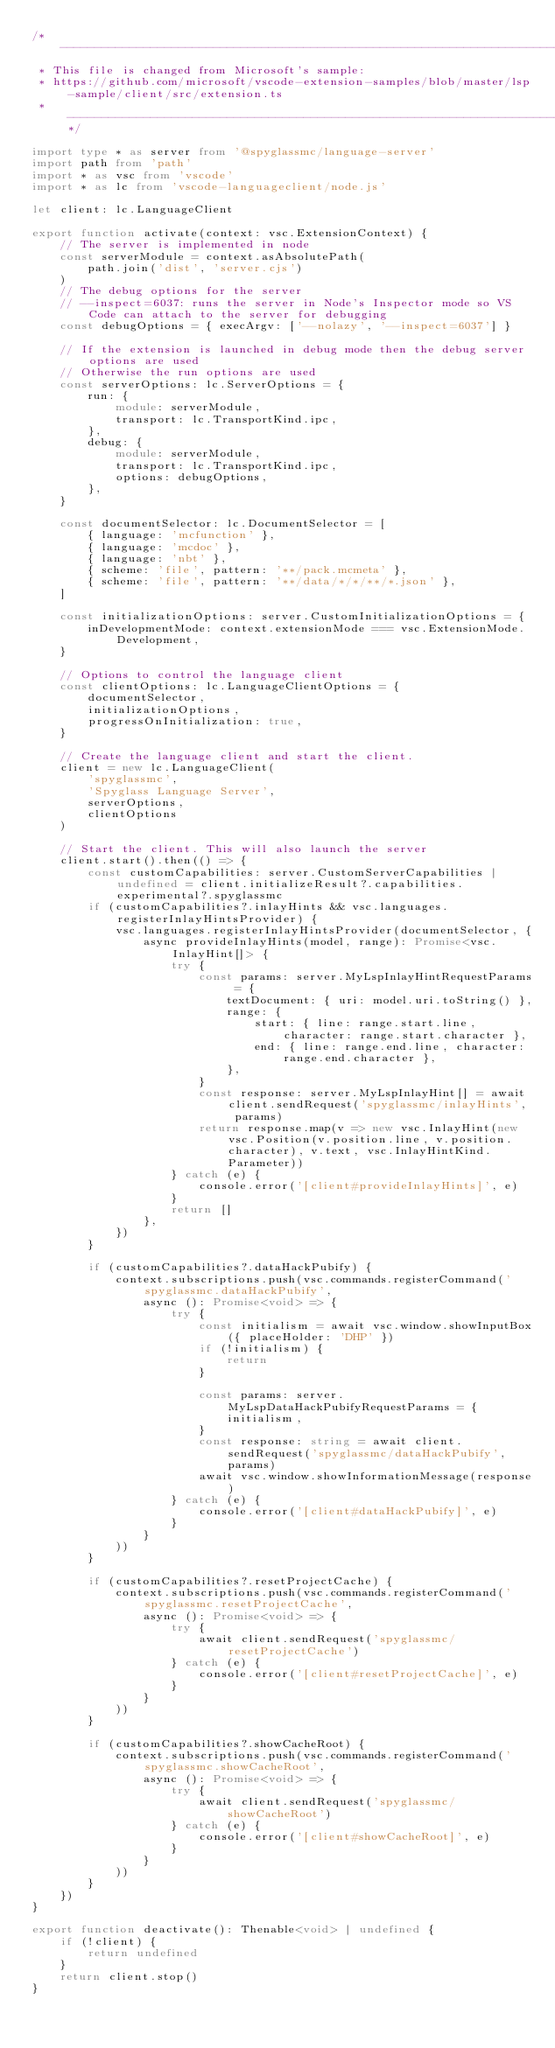<code> <loc_0><loc_0><loc_500><loc_500><_TypeScript_>/* --------------------------------------------------------------------------------------------
 * This file is changed from Microsoft's sample:
 * https://github.com/microsoft/vscode-extension-samples/blob/master/lsp-sample/client/src/extension.ts
 * ------------------------------------------------------------------------------------------*/

import type * as server from '@spyglassmc/language-server'
import path from 'path'
import * as vsc from 'vscode'
import * as lc from 'vscode-languageclient/node.js'

let client: lc.LanguageClient

export function activate(context: vsc.ExtensionContext) {
	// The server is implemented in node
	const serverModule = context.asAbsolutePath(
		path.join('dist', 'server.cjs')
	)
	// The debug options for the server
	// --inspect=6037: runs the server in Node's Inspector mode so VS Code can attach to the server for debugging
	const debugOptions = { execArgv: ['--nolazy', '--inspect=6037'] }

	// If the extension is launched in debug mode then the debug server options are used
	// Otherwise the run options are used
	const serverOptions: lc.ServerOptions = {
		run: {
			module: serverModule,
			transport: lc.TransportKind.ipc,
		},
		debug: {
			module: serverModule,
			transport: lc.TransportKind.ipc,
			options: debugOptions,
		},
	}

	const documentSelector: lc.DocumentSelector = [
		{ language: 'mcfunction' },
		{ language: 'mcdoc' },
		{ language: 'nbt' },
		{ scheme: 'file', pattern: '**/pack.mcmeta' },
		{ scheme: 'file', pattern: '**/data/*/*/**/*.json' },
	]

	const initializationOptions: server.CustomInitializationOptions = {
		inDevelopmentMode: context.extensionMode === vsc.ExtensionMode.Development,
	}

	// Options to control the language client
	const clientOptions: lc.LanguageClientOptions = {
		documentSelector,
		initializationOptions,
		progressOnInitialization: true,
	}

	// Create the language client and start the client.
	client = new lc.LanguageClient(
		'spyglassmc',
		'Spyglass Language Server',
		serverOptions,
		clientOptions
	)

	// Start the client. This will also launch the server
	client.start().then(() => {
		const customCapabilities: server.CustomServerCapabilities | undefined = client.initializeResult?.capabilities.experimental?.spyglassmc
		if (customCapabilities?.inlayHints && vsc.languages.registerInlayHintsProvider) {
			vsc.languages.registerInlayHintsProvider(documentSelector, {
				async provideInlayHints(model, range): Promise<vsc.InlayHint[]> {
					try {
						const params: server.MyLspInlayHintRequestParams = {
							textDocument: { uri: model.uri.toString() },
							range: {
								start: { line: range.start.line, character: range.start.character },
								end: { line: range.end.line, character: range.end.character },
							},
						}
						const response: server.MyLspInlayHint[] = await client.sendRequest('spyglassmc/inlayHints', params)
						return response.map(v => new vsc.InlayHint(new vsc.Position(v.position.line, v.position.character), v.text, vsc.InlayHintKind.Parameter))
					} catch (e) {
						console.error('[client#provideInlayHints]', e)
					}
					return []
				},
			})
		}

		if (customCapabilities?.dataHackPubify) {
			context.subscriptions.push(vsc.commands.registerCommand('spyglassmc.dataHackPubify',
				async (): Promise<void> => {
					try {
						const initialism = await vsc.window.showInputBox({ placeHolder: 'DHP' })
						if (!initialism) {
							return
						}

						const params: server.MyLspDataHackPubifyRequestParams = {
							initialism,
						}
						const response: string = await client.sendRequest('spyglassmc/dataHackPubify', params)
						await vsc.window.showInformationMessage(response)
					} catch (e) {
						console.error('[client#dataHackPubify]', e)
					}
				}
			))
		}

		if (customCapabilities?.resetProjectCache) {
			context.subscriptions.push(vsc.commands.registerCommand('spyglassmc.resetProjectCache',
				async (): Promise<void> => {
					try {
						await client.sendRequest('spyglassmc/resetProjectCache')
					} catch (e) {
						console.error('[client#resetProjectCache]', e)
					}
				}
			))
		}

		if (customCapabilities?.showCacheRoot) {
			context.subscriptions.push(vsc.commands.registerCommand('spyglassmc.showCacheRoot',
				async (): Promise<void> => {
					try {
						await client.sendRequest('spyglassmc/showCacheRoot')
					} catch (e) {
						console.error('[client#showCacheRoot]', e)
					}
				}
			))
		}
	})
}

export function deactivate(): Thenable<void> | undefined {
	if (!client) {
		return undefined
	}
	return client.stop()
}
</code> 